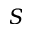<formula> <loc_0><loc_0><loc_500><loc_500>S</formula> 